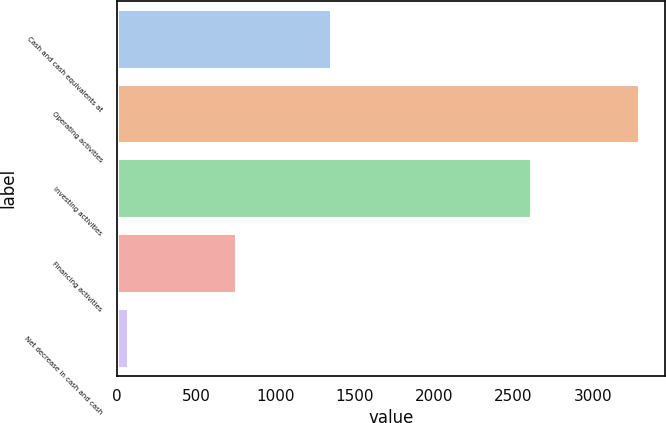Convert chart. <chart><loc_0><loc_0><loc_500><loc_500><bar_chart><fcel>Cash and cash equivalents at<fcel>Operating activities<fcel>Investing activities<fcel>Financing activities<fcel>Net decrease in cash and cash<nl><fcel>1351<fcel>3291<fcel>2609<fcel>753<fcel>71<nl></chart> 